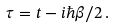Convert formula to latex. <formula><loc_0><loc_0><loc_500><loc_500>\tau = t - i \hbar { \beta } / 2 \, .</formula> 